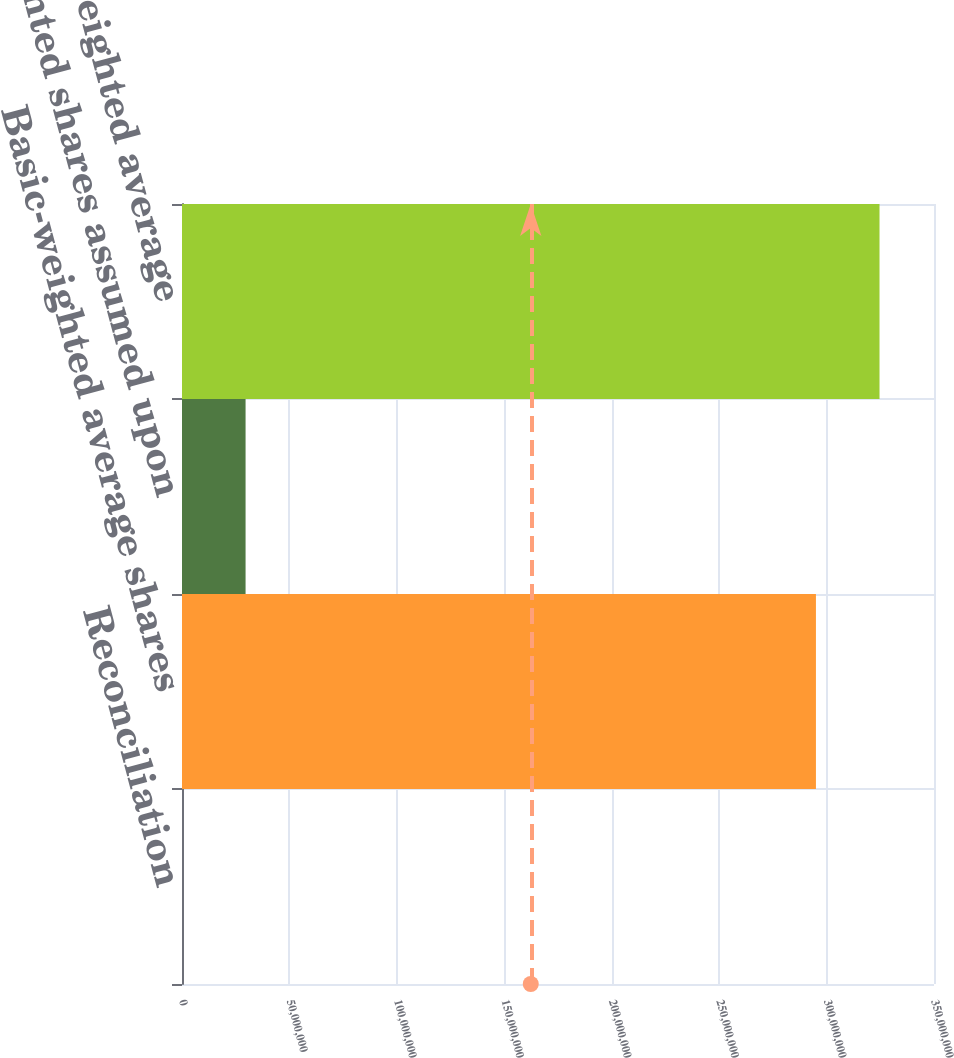Convert chart to OTSL. <chart><loc_0><loc_0><loc_500><loc_500><bar_chart><fcel>Reconciliation<fcel>Basic-weighted average shares<fcel>Weighted shares assumed upon<fcel>Diluted-weighted average<nl><fcel>2011<fcel>2.95054e+08<fcel>2.95887e+07<fcel>3.2464e+08<nl></chart> 